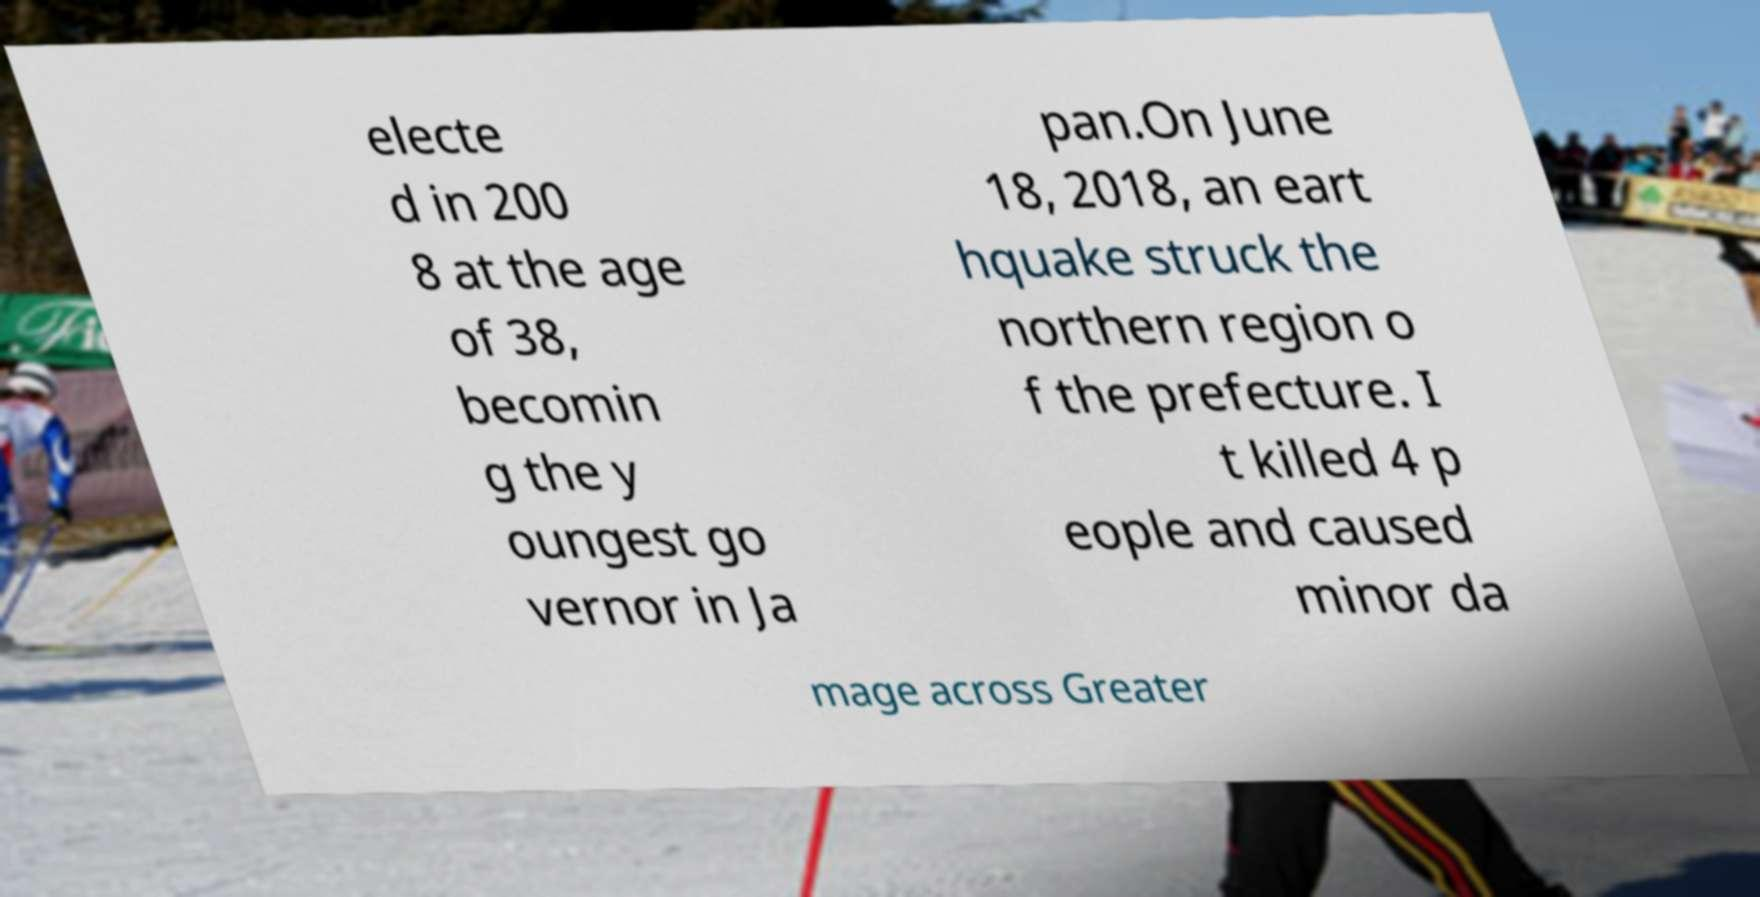What messages or text are displayed in this image? I need them in a readable, typed format. electe d in 200 8 at the age of 38, becomin g the y oungest go vernor in Ja pan.On June 18, 2018, an eart hquake struck the northern region o f the prefecture. I t killed 4 p eople and caused minor da mage across Greater 